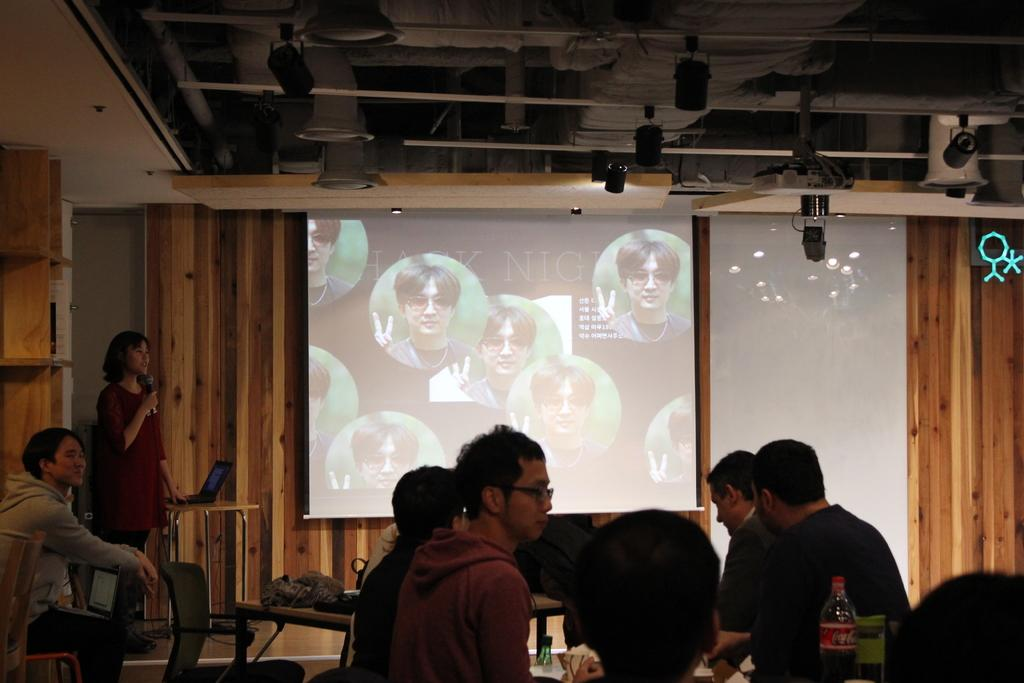How many people are in the group in the image? There is a group of people in the image, but the exact number is not specified. What are the people in the group doing? The people in the group are sitting on chairs. How are the chairs arranged in the image? The chairs are arranged around tables. What can be seen on the screen in the image? The facts do not specify what is on the screen. How many people are beside the group in the image? There are two other people beside the group in the image. What type of silk fabric is draped over the chairs in the image? There is no mention of silk fabric in the image; the chairs are simply described as being arranged around tables. 